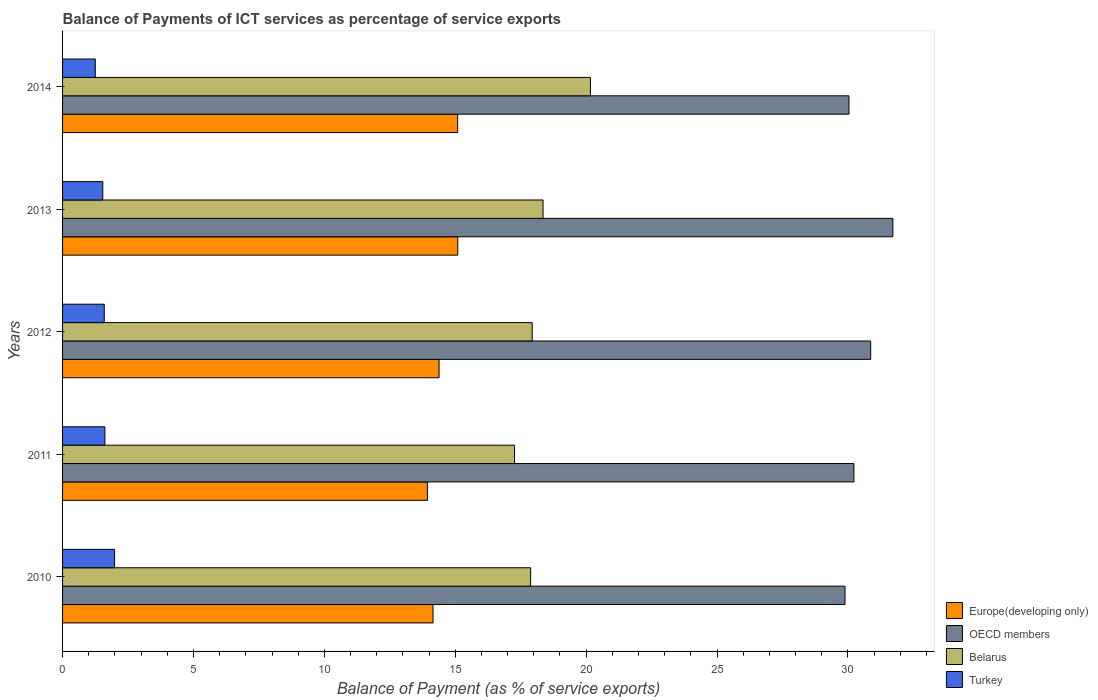How many bars are there on the 2nd tick from the top?
Your answer should be compact. 4. How many bars are there on the 5th tick from the bottom?
Your answer should be compact. 4. In how many cases, is the number of bars for a given year not equal to the number of legend labels?
Ensure brevity in your answer.  0. What is the balance of payments of ICT services in Turkey in 2013?
Give a very brief answer. 1.54. Across all years, what is the maximum balance of payments of ICT services in Belarus?
Provide a short and direct response. 20.16. Across all years, what is the minimum balance of payments of ICT services in Belarus?
Your response must be concise. 17.26. In which year was the balance of payments of ICT services in Turkey maximum?
Offer a terse response. 2010. In which year was the balance of payments of ICT services in Belarus minimum?
Your answer should be very brief. 2011. What is the total balance of payments of ICT services in OECD members in the graph?
Provide a succinct answer. 152.74. What is the difference between the balance of payments of ICT services in Belarus in 2010 and that in 2013?
Give a very brief answer. -0.47. What is the difference between the balance of payments of ICT services in Turkey in 2011 and the balance of payments of ICT services in OECD members in 2014?
Keep it short and to the point. -28.42. What is the average balance of payments of ICT services in Belarus per year?
Make the answer very short. 18.32. In the year 2010, what is the difference between the balance of payments of ICT services in Belarus and balance of payments of ICT services in Turkey?
Provide a succinct answer. 15.89. What is the ratio of the balance of payments of ICT services in Belarus in 2011 to that in 2014?
Your response must be concise. 0.86. Is the difference between the balance of payments of ICT services in Belarus in 2011 and 2012 greater than the difference between the balance of payments of ICT services in Turkey in 2011 and 2012?
Offer a terse response. No. What is the difference between the highest and the second highest balance of payments of ICT services in Europe(developing only)?
Offer a terse response. 0. What is the difference between the highest and the lowest balance of payments of ICT services in OECD members?
Your answer should be compact. 1.83. In how many years, is the balance of payments of ICT services in Europe(developing only) greater than the average balance of payments of ICT services in Europe(developing only) taken over all years?
Ensure brevity in your answer.  2. Is the sum of the balance of payments of ICT services in Turkey in 2013 and 2014 greater than the maximum balance of payments of ICT services in OECD members across all years?
Your response must be concise. No. What does the 1st bar from the bottom in 2013 represents?
Offer a terse response. Europe(developing only). What is the difference between two consecutive major ticks on the X-axis?
Offer a very short reply. 5. Are the values on the major ticks of X-axis written in scientific E-notation?
Provide a short and direct response. No. Does the graph contain any zero values?
Offer a very short reply. No. Does the graph contain grids?
Provide a short and direct response. No. Where does the legend appear in the graph?
Give a very brief answer. Bottom right. How many legend labels are there?
Provide a short and direct response. 4. How are the legend labels stacked?
Make the answer very short. Vertical. What is the title of the graph?
Your answer should be very brief. Balance of Payments of ICT services as percentage of service exports. Does "Saudi Arabia" appear as one of the legend labels in the graph?
Provide a short and direct response. No. What is the label or title of the X-axis?
Your response must be concise. Balance of Payment (as % of service exports). What is the Balance of Payment (as % of service exports) in Europe(developing only) in 2010?
Your response must be concise. 14.15. What is the Balance of Payment (as % of service exports) of OECD members in 2010?
Offer a terse response. 29.89. What is the Balance of Payment (as % of service exports) of Belarus in 2010?
Offer a very short reply. 17.88. What is the Balance of Payment (as % of service exports) of Turkey in 2010?
Offer a terse response. 1.99. What is the Balance of Payment (as % of service exports) of Europe(developing only) in 2011?
Your answer should be compact. 13.94. What is the Balance of Payment (as % of service exports) of OECD members in 2011?
Give a very brief answer. 30.23. What is the Balance of Payment (as % of service exports) of Belarus in 2011?
Your answer should be compact. 17.26. What is the Balance of Payment (as % of service exports) of Turkey in 2011?
Your answer should be compact. 1.62. What is the Balance of Payment (as % of service exports) in Europe(developing only) in 2012?
Your answer should be compact. 14.38. What is the Balance of Payment (as % of service exports) in OECD members in 2012?
Your answer should be compact. 30.87. What is the Balance of Payment (as % of service exports) in Belarus in 2012?
Provide a succinct answer. 17.94. What is the Balance of Payment (as % of service exports) in Turkey in 2012?
Keep it short and to the point. 1.59. What is the Balance of Payment (as % of service exports) of Europe(developing only) in 2013?
Provide a short and direct response. 15.1. What is the Balance of Payment (as % of service exports) of OECD members in 2013?
Your answer should be very brief. 31.72. What is the Balance of Payment (as % of service exports) of Belarus in 2013?
Give a very brief answer. 18.35. What is the Balance of Payment (as % of service exports) of Turkey in 2013?
Your response must be concise. 1.54. What is the Balance of Payment (as % of service exports) of Europe(developing only) in 2014?
Your answer should be very brief. 15.09. What is the Balance of Payment (as % of service exports) of OECD members in 2014?
Provide a succinct answer. 30.04. What is the Balance of Payment (as % of service exports) in Belarus in 2014?
Your answer should be compact. 20.16. What is the Balance of Payment (as % of service exports) of Turkey in 2014?
Provide a short and direct response. 1.25. Across all years, what is the maximum Balance of Payment (as % of service exports) of Europe(developing only)?
Provide a succinct answer. 15.1. Across all years, what is the maximum Balance of Payment (as % of service exports) in OECD members?
Your answer should be compact. 31.72. Across all years, what is the maximum Balance of Payment (as % of service exports) of Belarus?
Offer a terse response. 20.16. Across all years, what is the maximum Balance of Payment (as % of service exports) in Turkey?
Your response must be concise. 1.99. Across all years, what is the minimum Balance of Payment (as % of service exports) in Europe(developing only)?
Make the answer very short. 13.94. Across all years, what is the minimum Balance of Payment (as % of service exports) of OECD members?
Provide a succinct answer. 29.89. Across all years, what is the minimum Balance of Payment (as % of service exports) of Belarus?
Keep it short and to the point. 17.26. Across all years, what is the minimum Balance of Payment (as % of service exports) in Turkey?
Ensure brevity in your answer.  1.25. What is the total Balance of Payment (as % of service exports) of Europe(developing only) in the graph?
Offer a very short reply. 72.66. What is the total Balance of Payment (as % of service exports) of OECD members in the graph?
Keep it short and to the point. 152.74. What is the total Balance of Payment (as % of service exports) of Belarus in the graph?
Provide a succinct answer. 91.6. What is the total Balance of Payment (as % of service exports) of Turkey in the graph?
Make the answer very short. 7.98. What is the difference between the Balance of Payment (as % of service exports) of Europe(developing only) in 2010 and that in 2011?
Make the answer very short. 0.21. What is the difference between the Balance of Payment (as % of service exports) of OECD members in 2010 and that in 2011?
Offer a terse response. -0.34. What is the difference between the Balance of Payment (as % of service exports) in Belarus in 2010 and that in 2011?
Provide a short and direct response. 0.62. What is the difference between the Balance of Payment (as % of service exports) in Turkey in 2010 and that in 2011?
Ensure brevity in your answer.  0.37. What is the difference between the Balance of Payment (as % of service exports) of Europe(developing only) in 2010 and that in 2012?
Give a very brief answer. -0.23. What is the difference between the Balance of Payment (as % of service exports) of OECD members in 2010 and that in 2012?
Ensure brevity in your answer.  -0.98. What is the difference between the Balance of Payment (as % of service exports) in Belarus in 2010 and that in 2012?
Provide a succinct answer. -0.06. What is the difference between the Balance of Payment (as % of service exports) of Turkey in 2010 and that in 2012?
Offer a very short reply. 0.39. What is the difference between the Balance of Payment (as % of service exports) of Europe(developing only) in 2010 and that in 2013?
Provide a succinct answer. -0.95. What is the difference between the Balance of Payment (as % of service exports) in OECD members in 2010 and that in 2013?
Offer a terse response. -1.83. What is the difference between the Balance of Payment (as % of service exports) in Belarus in 2010 and that in 2013?
Ensure brevity in your answer.  -0.47. What is the difference between the Balance of Payment (as % of service exports) in Turkey in 2010 and that in 2013?
Keep it short and to the point. 0.45. What is the difference between the Balance of Payment (as % of service exports) in Europe(developing only) in 2010 and that in 2014?
Ensure brevity in your answer.  -0.94. What is the difference between the Balance of Payment (as % of service exports) of OECD members in 2010 and that in 2014?
Your response must be concise. -0.15. What is the difference between the Balance of Payment (as % of service exports) in Belarus in 2010 and that in 2014?
Provide a short and direct response. -2.28. What is the difference between the Balance of Payment (as % of service exports) in Turkey in 2010 and that in 2014?
Your answer should be very brief. 0.74. What is the difference between the Balance of Payment (as % of service exports) of Europe(developing only) in 2011 and that in 2012?
Keep it short and to the point. -0.44. What is the difference between the Balance of Payment (as % of service exports) of OECD members in 2011 and that in 2012?
Keep it short and to the point. -0.64. What is the difference between the Balance of Payment (as % of service exports) of Belarus in 2011 and that in 2012?
Make the answer very short. -0.67. What is the difference between the Balance of Payment (as % of service exports) of Turkey in 2011 and that in 2012?
Give a very brief answer. 0.02. What is the difference between the Balance of Payment (as % of service exports) of Europe(developing only) in 2011 and that in 2013?
Give a very brief answer. -1.16. What is the difference between the Balance of Payment (as % of service exports) of OECD members in 2011 and that in 2013?
Ensure brevity in your answer.  -1.49. What is the difference between the Balance of Payment (as % of service exports) of Belarus in 2011 and that in 2013?
Keep it short and to the point. -1.09. What is the difference between the Balance of Payment (as % of service exports) in Turkey in 2011 and that in 2013?
Offer a terse response. 0.08. What is the difference between the Balance of Payment (as % of service exports) of Europe(developing only) in 2011 and that in 2014?
Make the answer very short. -1.15. What is the difference between the Balance of Payment (as % of service exports) of OECD members in 2011 and that in 2014?
Keep it short and to the point. 0.19. What is the difference between the Balance of Payment (as % of service exports) in Belarus in 2011 and that in 2014?
Your response must be concise. -2.9. What is the difference between the Balance of Payment (as % of service exports) of Turkey in 2011 and that in 2014?
Your answer should be compact. 0.37. What is the difference between the Balance of Payment (as % of service exports) of Europe(developing only) in 2012 and that in 2013?
Offer a very short reply. -0.71. What is the difference between the Balance of Payment (as % of service exports) in OECD members in 2012 and that in 2013?
Your answer should be very brief. -0.85. What is the difference between the Balance of Payment (as % of service exports) in Belarus in 2012 and that in 2013?
Your answer should be compact. -0.42. What is the difference between the Balance of Payment (as % of service exports) in Turkey in 2012 and that in 2013?
Your answer should be very brief. 0.06. What is the difference between the Balance of Payment (as % of service exports) of Europe(developing only) in 2012 and that in 2014?
Give a very brief answer. -0.71. What is the difference between the Balance of Payment (as % of service exports) of OECD members in 2012 and that in 2014?
Give a very brief answer. 0.83. What is the difference between the Balance of Payment (as % of service exports) in Belarus in 2012 and that in 2014?
Ensure brevity in your answer.  -2.22. What is the difference between the Balance of Payment (as % of service exports) in Turkey in 2012 and that in 2014?
Your answer should be very brief. 0.34. What is the difference between the Balance of Payment (as % of service exports) in Europe(developing only) in 2013 and that in 2014?
Provide a succinct answer. 0. What is the difference between the Balance of Payment (as % of service exports) of OECD members in 2013 and that in 2014?
Your answer should be very brief. 1.68. What is the difference between the Balance of Payment (as % of service exports) of Belarus in 2013 and that in 2014?
Ensure brevity in your answer.  -1.81. What is the difference between the Balance of Payment (as % of service exports) in Turkey in 2013 and that in 2014?
Keep it short and to the point. 0.29. What is the difference between the Balance of Payment (as % of service exports) in Europe(developing only) in 2010 and the Balance of Payment (as % of service exports) in OECD members in 2011?
Ensure brevity in your answer.  -16.08. What is the difference between the Balance of Payment (as % of service exports) in Europe(developing only) in 2010 and the Balance of Payment (as % of service exports) in Belarus in 2011?
Your answer should be compact. -3.11. What is the difference between the Balance of Payment (as % of service exports) of Europe(developing only) in 2010 and the Balance of Payment (as % of service exports) of Turkey in 2011?
Provide a short and direct response. 12.53. What is the difference between the Balance of Payment (as % of service exports) of OECD members in 2010 and the Balance of Payment (as % of service exports) of Belarus in 2011?
Offer a terse response. 12.62. What is the difference between the Balance of Payment (as % of service exports) in OECD members in 2010 and the Balance of Payment (as % of service exports) in Turkey in 2011?
Offer a very short reply. 28.27. What is the difference between the Balance of Payment (as % of service exports) in Belarus in 2010 and the Balance of Payment (as % of service exports) in Turkey in 2011?
Your response must be concise. 16.26. What is the difference between the Balance of Payment (as % of service exports) in Europe(developing only) in 2010 and the Balance of Payment (as % of service exports) in OECD members in 2012?
Give a very brief answer. -16.72. What is the difference between the Balance of Payment (as % of service exports) in Europe(developing only) in 2010 and the Balance of Payment (as % of service exports) in Belarus in 2012?
Keep it short and to the point. -3.79. What is the difference between the Balance of Payment (as % of service exports) of Europe(developing only) in 2010 and the Balance of Payment (as % of service exports) of Turkey in 2012?
Your answer should be compact. 12.56. What is the difference between the Balance of Payment (as % of service exports) in OECD members in 2010 and the Balance of Payment (as % of service exports) in Belarus in 2012?
Provide a succinct answer. 11.95. What is the difference between the Balance of Payment (as % of service exports) in OECD members in 2010 and the Balance of Payment (as % of service exports) in Turkey in 2012?
Your answer should be compact. 28.29. What is the difference between the Balance of Payment (as % of service exports) of Belarus in 2010 and the Balance of Payment (as % of service exports) of Turkey in 2012?
Ensure brevity in your answer.  16.29. What is the difference between the Balance of Payment (as % of service exports) in Europe(developing only) in 2010 and the Balance of Payment (as % of service exports) in OECD members in 2013?
Your answer should be very brief. -17.57. What is the difference between the Balance of Payment (as % of service exports) of Europe(developing only) in 2010 and the Balance of Payment (as % of service exports) of Belarus in 2013?
Offer a very short reply. -4.2. What is the difference between the Balance of Payment (as % of service exports) of Europe(developing only) in 2010 and the Balance of Payment (as % of service exports) of Turkey in 2013?
Ensure brevity in your answer.  12.61. What is the difference between the Balance of Payment (as % of service exports) of OECD members in 2010 and the Balance of Payment (as % of service exports) of Belarus in 2013?
Your answer should be compact. 11.53. What is the difference between the Balance of Payment (as % of service exports) of OECD members in 2010 and the Balance of Payment (as % of service exports) of Turkey in 2013?
Your answer should be compact. 28.35. What is the difference between the Balance of Payment (as % of service exports) in Belarus in 2010 and the Balance of Payment (as % of service exports) in Turkey in 2013?
Keep it short and to the point. 16.34. What is the difference between the Balance of Payment (as % of service exports) in Europe(developing only) in 2010 and the Balance of Payment (as % of service exports) in OECD members in 2014?
Provide a short and direct response. -15.89. What is the difference between the Balance of Payment (as % of service exports) in Europe(developing only) in 2010 and the Balance of Payment (as % of service exports) in Belarus in 2014?
Provide a succinct answer. -6.01. What is the difference between the Balance of Payment (as % of service exports) of Europe(developing only) in 2010 and the Balance of Payment (as % of service exports) of Turkey in 2014?
Offer a terse response. 12.9. What is the difference between the Balance of Payment (as % of service exports) in OECD members in 2010 and the Balance of Payment (as % of service exports) in Belarus in 2014?
Offer a very short reply. 9.72. What is the difference between the Balance of Payment (as % of service exports) in OECD members in 2010 and the Balance of Payment (as % of service exports) in Turkey in 2014?
Your response must be concise. 28.64. What is the difference between the Balance of Payment (as % of service exports) in Belarus in 2010 and the Balance of Payment (as % of service exports) in Turkey in 2014?
Your answer should be very brief. 16.63. What is the difference between the Balance of Payment (as % of service exports) in Europe(developing only) in 2011 and the Balance of Payment (as % of service exports) in OECD members in 2012?
Provide a succinct answer. -16.93. What is the difference between the Balance of Payment (as % of service exports) in Europe(developing only) in 2011 and the Balance of Payment (as % of service exports) in Belarus in 2012?
Make the answer very short. -4. What is the difference between the Balance of Payment (as % of service exports) in Europe(developing only) in 2011 and the Balance of Payment (as % of service exports) in Turkey in 2012?
Ensure brevity in your answer.  12.34. What is the difference between the Balance of Payment (as % of service exports) in OECD members in 2011 and the Balance of Payment (as % of service exports) in Belarus in 2012?
Your response must be concise. 12.29. What is the difference between the Balance of Payment (as % of service exports) in OECD members in 2011 and the Balance of Payment (as % of service exports) in Turkey in 2012?
Your response must be concise. 28.64. What is the difference between the Balance of Payment (as % of service exports) of Belarus in 2011 and the Balance of Payment (as % of service exports) of Turkey in 2012?
Provide a short and direct response. 15.67. What is the difference between the Balance of Payment (as % of service exports) of Europe(developing only) in 2011 and the Balance of Payment (as % of service exports) of OECD members in 2013?
Give a very brief answer. -17.78. What is the difference between the Balance of Payment (as % of service exports) in Europe(developing only) in 2011 and the Balance of Payment (as % of service exports) in Belarus in 2013?
Ensure brevity in your answer.  -4.42. What is the difference between the Balance of Payment (as % of service exports) of Europe(developing only) in 2011 and the Balance of Payment (as % of service exports) of Turkey in 2013?
Your response must be concise. 12.4. What is the difference between the Balance of Payment (as % of service exports) in OECD members in 2011 and the Balance of Payment (as % of service exports) in Belarus in 2013?
Provide a succinct answer. 11.88. What is the difference between the Balance of Payment (as % of service exports) of OECD members in 2011 and the Balance of Payment (as % of service exports) of Turkey in 2013?
Offer a very short reply. 28.69. What is the difference between the Balance of Payment (as % of service exports) of Belarus in 2011 and the Balance of Payment (as % of service exports) of Turkey in 2013?
Keep it short and to the point. 15.73. What is the difference between the Balance of Payment (as % of service exports) in Europe(developing only) in 2011 and the Balance of Payment (as % of service exports) in OECD members in 2014?
Your answer should be very brief. -16.1. What is the difference between the Balance of Payment (as % of service exports) in Europe(developing only) in 2011 and the Balance of Payment (as % of service exports) in Belarus in 2014?
Provide a short and direct response. -6.23. What is the difference between the Balance of Payment (as % of service exports) in Europe(developing only) in 2011 and the Balance of Payment (as % of service exports) in Turkey in 2014?
Ensure brevity in your answer.  12.69. What is the difference between the Balance of Payment (as % of service exports) in OECD members in 2011 and the Balance of Payment (as % of service exports) in Belarus in 2014?
Keep it short and to the point. 10.07. What is the difference between the Balance of Payment (as % of service exports) of OECD members in 2011 and the Balance of Payment (as % of service exports) of Turkey in 2014?
Your answer should be very brief. 28.98. What is the difference between the Balance of Payment (as % of service exports) in Belarus in 2011 and the Balance of Payment (as % of service exports) in Turkey in 2014?
Your response must be concise. 16.01. What is the difference between the Balance of Payment (as % of service exports) in Europe(developing only) in 2012 and the Balance of Payment (as % of service exports) in OECD members in 2013?
Make the answer very short. -17.34. What is the difference between the Balance of Payment (as % of service exports) of Europe(developing only) in 2012 and the Balance of Payment (as % of service exports) of Belarus in 2013?
Make the answer very short. -3.97. What is the difference between the Balance of Payment (as % of service exports) of Europe(developing only) in 2012 and the Balance of Payment (as % of service exports) of Turkey in 2013?
Offer a terse response. 12.85. What is the difference between the Balance of Payment (as % of service exports) of OECD members in 2012 and the Balance of Payment (as % of service exports) of Belarus in 2013?
Ensure brevity in your answer.  12.52. What is the difference between the Balance of Payment (as % of service exports) of OECD members in 2012 and the Balance of Payment (as % of service exports) of Turkey in 2013?
Make the answer very short. 29.33. What is the difference between the Balance of Payment (as % of service exports) of Belarus in 2012 and the Balance of Payment (as % of service exports) of Turkey in 2013?
Offer a terse response. 16.4. What is the difference between the Balance of Payment (as % of service exports) in Europe(developing only) in 2012 and the Balance of Payment (as % of service exports) in OECD members in 2014?
Offer a terse response. -15.66. What is the difference between the Balance of Payment (as % of service exports) of Europe(developing only) in 2012 and the Balance of Payment (as % of service exports) of Belarus in 2014?
Ensure brevity in your answer.  -5.78. What is the difference between the Balance of Payment (as % of service exports) in Europe(developing only) in 2012 and the Balance of Payment (as % of service exports) in Turkey in 2014?
Keep it short and to the point. 13.13. What is the difference between the Balance of Payment (as % of service exports) of OECD members in 2012 and the Balance of Payment (as % of service exports) of Belarus in 2014?
Your answer should be compact. 10.71. What is the difference between the Balance of Payment (as % of service exports) in OECD members in 2012 and the Balance of Payment (as % of service exports) in Turkey in 2014?
Offer a terse response. 29.62. What is the difference between the Balance of Payment (as % of service exports) in Belarus in 2012 and the Balance of Payment (as % of service exports) in Turkey in 2014?
Provide a short and direct response. 16.69. What is the difference between the Balance of Payment (as % of service exports) of Europe(developing only) in 2013 and the Balance of Payment (as % of service exports) of OECD members in 2014?
Provide a short and direct response. -14.94. What is the difference between the Balance of Payment (as % of service exports) of Europe(developing only) in 2013 and the Balance of Payment (as % of service exports) of Belarus in 2014?
Your answer should be very brief. -5.07. What is the difference between the Balance of Payment (as % of service exports) of Europe(developing only) in 2013 and the Balance of Payment (as % of service exports) of Turkey in 2014?
Provide a succinct answer. 13.85. What is the difference between the Balance of Payment (as % of service exports) of OECD members in 2013 and the Balance of Payment (as % of service exports) of Belarus in 2014?
Your answer should be very brief. 11.55. What is the difference between the Balance of Payment (as % of service exports) of OECD members in 2013 and the Balance of Payment (as % of service exports) of Turkey in 2014?
Make the answer very short. 30.47. What is the difference between the Balance of Payment (as % of service exports) in Belarus in 2013 and the Balance of Payment (as % of service exports) in Turkey in 2014?
Provide a succinct answer. 17.1. What is the average Balance of Payment (as % of service exports) of Europe(developing only) per year?
Your response must be concise. 14.53. What is the average Balance of Payment (as % of service exports) in OECD members per year?
Your answer should be compact. 30.55. What is the average Balance of Payment (as % of service exports) in Belarus per year?
Keep it short and to the point. 18.32. What is the average Balance of Payment (as % of service exports) of Turkey per year?
Your answer should be very brief. 1.6. In the year 2010, what is the difference between the Balance of Payment (as % of service exports) in Europe(developing only) and Balance of Payment (as % of service exports) in OECD members?
Ensure brevity in your answer.  -15.74. In the year 2010, what is the difference between the Balance of Payment (as % of service exports) in Europe(developing only) and Balance of Payment (as % of service exports) in Belarus?
Provide a short and direct response. -3.73. In the year 2010, what is the difference between the Balance of Payment (as % of service exports) in Europe(developing only) and Balance of Payment (as % of service exports) in Turkey?
Make the answer very short. 12.16. In the year 2010, what is the difference between the Balance of Payment (as % of service exports) in OECD members and Balance of Payment (as % of service exports) in Belarus?
Make the answer very short. 12.01. In the year 2010, what is the difference between the Balance of Payment (as % of service exports) of OECD members and Balance of Payment (as % of service exports) of Turkey?
Offer a very short reply. 27.9. In the year 2010, what is the difference between the Balance of Payment (as % of service exports) in Belarus and Balance of Payment (as % of service exports) in Turkey?
Offer a terse response. 15.89. In the year 2011, what is the difference between the Balance of Payment (as % of service exports) of Europe(developing only) and Balance of Payment (as % of service exports) of OECD members?
Provide a short and direct response. -16.29. In the year 2011, what is the difference between the Balance of Payment (as % of service exports) of Europe(developing only) and Balance of Payment (as % of service exports) of Belarus?
Give a very brief answer. -3.33. In the year 2011, what is the difference between the Balance of Payment (as % of service exports) of Europe(developing only) and Balance of Payment (as % of service exports) of Turkey?
Make the answer very short. 12.32. In the year 2011, what is the difference between the Balance of Payment (as % of service exports) of OECD members and Balance of Payment (as % of service exports) of Belarus?
Your answer should be very brief. 12.96. In the year 2011, what is the difference between the Balance of Payment (as % of service exports) of OECD members and Balance of Payment (as % of service exports) of Turkey?
Offer a terse response. 28.61. In the year 2011, what is the difference between the Balance of Payment (as % of service exports) in Belarus and Balance of Payment (as % of service exports) in Turkey?
Give a very brief answer. 15.65. In the year 2012, what is the difference between the Balance of Payment (as % of service exports) of Europe(developing only) and Balance of Payment (as % of service exports) of OECD members?
Give a very brief answer. -16.49. In the year 2012, what is the difference between the Balance of Payment (as % of service exports) of Europe(developing only) and Balance of Payment (as % of service exports) of Belarus?
Offer a terse response. -3.56. In the year 2012, what is the difference between the Balance of Payment (as % of service exports) of Europe(developing only) and Balance of Payment (as % of service exports) of Turkey?
Offer a terse response. 12.79. In the year 2012, what is the difference between the Balance of Payment (as % of service exports) in OECD members and Balance of Payment (as % of service exports) in Belarus?
Keep it short and to the point. 12.93. In the year 2012, what is the difference between the Balance of Payment (as % of service exports) in OECD members and Balance of Payment (as % of service exports) in Turkey?
Keep it short and to the point. 29.28. In the year 2012, what is the difference between the Balance of Payment (as % of service exports) in Belarus and Balance of Payment (as % of service exports) in Turkey?
Ensure brevity in your answer.  16.35. In the year 2013, what is the difference between the Balance of Payment (as % of service exports) of Europe(developing only) and Balance of Payment (as % of service exports) of OECD members?
Give a very brief answer. -16.62. In the year 2013, what is the difference between the Balance of Payment (as % of service exports) of Europe(developing only) and Balance of Payment (as % of service exports) of Belarus?
Give a very brief answer. -3.26. In the year 2013, what is the difference between the Balance of Payment (as % of service exports) in Europe(developing only) and Balance of Payment (as % of service exports) in Turkey?
Your response must be concise. 13.56. In the year 2013, what is the difference between the Balance of Payment (as % of service exports) in OECD members and Balance of Payment (as % of service exports) in Belarus?
Keep it short and to the point. 13.36. In the year 2013, what is the difference between the Balance of Payment (as % of service exports) of OECD members and Balance of Payment (as % of service exports) of Turkey?
Provide a short and direct response. 30.18. In the year 2013, what is the difference between the Balance of Payment (as % of service exports) in Belarus and Balance of Payment (as % of service exports) in Turkey?
Keep it short and to the point. 16.82. In the year 2014, what is the difference between the Balance of Payment (as % of service exports) of Europe(developing only) and Balance of Payment (as % of service exports) of OECD members?
Give a very brief answer. -14.95. In the year 2014, what is the difference between the Balance of Payment (as % of service exports) in Europe(developing only) and Balance of Payment (as % of service exports) in Belarus?
Make the answer very short. -5.07. In the year 2014, what is the difference between the Balance of Payment (as % of service exports) in Europe(developing only) and Balance of Payment (as % of service exports) in Turkey?
Make the answer very short. 13.84. In the year 2014, what is the difference between the Balance of Payment (as % of service exports) in OECD members and Balance of Payment (as % of service exports) in Belarus?
Your response must be concise. 9.88. In the year 2014, what is the difference between the Balance of Payment (as % of service exports) of OECD members and Balance of Payment (as % of service exports) of Turkey?
Keep it short and to the point. 28.79. In the year 2014, what is the difference between the Balance of Payment (as % of service exports) of Belarus and Balance of Payment (as % of service exports) of Turkey?
Your answer should be compact. 18.91. What is the ratio of the Balance of Payment (as % of service exports) in Europe(developing only) in 2010 to that in 2011?
Offer a terse response. 1.02. What is the ratio of the Balance of Payment (as % of service exports) in OECD members in 2010 to that in 2011?
Offer a terse response. 0.99. What is the ratio of the Balance of Payment (as % of service exports) in Belarus in 2010 to that in 2011?
Offer a terse response. 1.04. What is the ratio of the Balance of Payment (as % of service exports) of Turkey in 2010 to that in 2011?
Offer a very short reply. 1.23. What is the ratio of the Balance of Payment (as % of service exports) of Europe(developing only) in 2010 to that in 2012?
Offer a terse response. 0.98. What is the ratio of the Balance of Payment (as % of service exports) in OECD members in 2010 to that in 2012?
Your answer should be compact. 0.97. What is the ratio of the Balance of Payment (as % of service exports) of Turkey in 2010 to that in 2012?
Provide a succinct answer. 1.25. What is the ratio of the Balance of Payment (as % of service exports) in Europe(developing only) in 2010 to that in 2013?
Keep it short and to the point. 0.94. What is the ratio of the Balance of Payment (as % of service exports) in OECD members in 2010 to that in 2013?
Make the answer very short. 0.94. What is the ratio of the Balance of Payment (as % of service exports) of Belarus in 2010 to that in 2013?
Give a very brief answer. 0.97. What is the ratio of the Balance of Payment (as % of service exports) of Turkey in 2010 to that in 2013?
Provide a succinct answer. 1.29. What is the ratio of the Balance of Payment (as % of service exports) in Europe(developing only) in 2010 to that in 2014?
Keep it short and to the point. 0.94. What is the ratio of the Balance of Payment (as % of service exports) of Belarus in 2010 to that in 2014?
Offer a terse response. 0.89. What is the ratio of the Balance of Payment (as % of service exports) of Turkey in 2010 to that in 2014?
Provide a succinct answer. 1.59. What is the ratio of the Balance of Payment (as % of service exports) in Europe(developing only) in 2011 to that in 2012?
Provide a succinct answer. 0.97. What is the ratio of the Balance of Payment (as % of service exports) of OECD members in 2011 to that in 2012?
Provide a short and direct response. 0.98. What is the ratio of the Balance of Payment (as % of service exports) in Belarus in 2011 to that in 2012?
Your response must be concise. 0.96. What is the ratio of the Balance of Payment (as % of service exports) in Turkey in 2011 to that in 2012?
Provide a succinct answer. 1.01. What is the ratio of the Balance of Payment (as % of service exports) in Europe(developing only) in 2011 to that in 2013?
Offer a very short reply. 0.92. What is the ratio of the Balance of Payment (as % of service exports) in OECD members in 2011 to that in 2013?
Your response must be concise. 0.95. What is the ratio of the Balance of Payment (as % of service exports) of Belarus in 2011 to that in 2013?
Offer a terse response. 0.94. What is the ratio of the Balance of Payment (as % of service exports) of Turkey in 2011 to that in 2013?
Make the answer very short. 1.05. What is the ratio of the Balance of Payment (as % of service exports) in Europe(developing only) in 2011 to that in 2014?
Offer a terse response. 0.92. What is the ratio of the Balance of Payment (as % of service exports) in Belarus in 2011 to that in 2014?
Ensure brevity in your answer.  0.86. What is the ratio of the Balance of Payment (as % of service exports) of Turkey in 2011 to that in 2014?
Offer a very short reply. 1.29. What is the ratio of the Balance of Payment (as % of service exports) in Europe(developing only) in 2012 to that in 2013?
Your response must be concise. 0.95. What is the ratio of the Balance of Payment (as % of service exports) in OECD members in 2012 to that in 2013?
Your answer should be very brief. 0.97. What is the ratio of the Balance of Payment (as % of service exports) in Belarus in 2012 to that in 2013?
Provide a short and direct response. 0.98. What is the ratio of the Balance of Payment (as % of service exports) of Turkey in 2012 to that in 2013?
Give a very brief answer. 1.04. What is the ratio of the Balance of Payment (as % of service exports) in Europe(developing only) in 2012 to that in 2014?
Ensure brevity in your answer.  0.95. What is the ratio of the Balance of Payment (as % of service exports) in OECD members in 2012 to that in 2014?
Your answer should be very brief. 1.03. What is the ratio of the Balance of Payment (as % of service exports) of Belarus in 2012 to that in 2014?
Your answer should be compact. 0.89. What is the ratio of the Balance of Payment (as % of service exports) of Turkey in 2012 to that in 2014?
Your answer should be compact. 1.27. What is the ratio of the Balance of Payment (as % of service exports) of Europe(developing only) in 2013 to that in 2014?
Your answer should be very brief. 1. What is the ratio of the Balance of Payment (as % of service exports) in OECD members in 2013 to that in 2014?
Your answer should be very brief. 1.06. What is the ratio of the Balance of Payment (as % of service exports) of Belarus in 2013 to that in 2014?
Your answer should be very brief. 0.91. What is the ratio of the Balance of Payment (as % of service exports) of Turkey in 2013 to that in 2014?
Give a very brief answer. 1.23. What is the difference between the highest and the second highest Balance of Payment (as % of service exports) in Europe(developing only)?
Your answer should be compact. 0. What is the difference between the highest and the second highest Balance of Payment (as % of service exports) in OECD members?
Make the answer very short. 0.85. What is the difference between the highest and the second highest Balance of Payment (as % of service exports) in Belarus?
Ensure brevity in your answer.  1.81. What is the difference between the highest and the second highest Balance of Payment (as % of service exports) of Turkey?
Give a very brief answer. 0.37. What is the difference between the highest and the lowest Balance of Payment (as % of service exports) of Europe(developing only)?
Your answer should be compact. 1.16. What is the difference between the highest and the lowest Balance of Payment (as % of service exports) of OECD members?
Keep it short and to the point. 1.83. What is the difference between the highest and the lowest Balance of Payment (as % of service exports) of Belarus?
Your answer should be compact. 2.9. What is the difference between the highest and the lowest Balance of Payment (as % of service exports) in Turkey?
Provide a short and direct response. 0.74. 